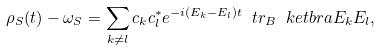<formula> <loc_0><loc_0><loc_500><loc_500>\rho _ { S } ( t ) - \omega _ { S } = \sum _ { k \neq l } c _ { k } c _ { l } ^ { * } e ^ { - i ( E _ { k } - E _ { l } ) t } \ t r _ { B } \ k e t b r a { E _ { k } } { E _ { l } } ,</formula> 